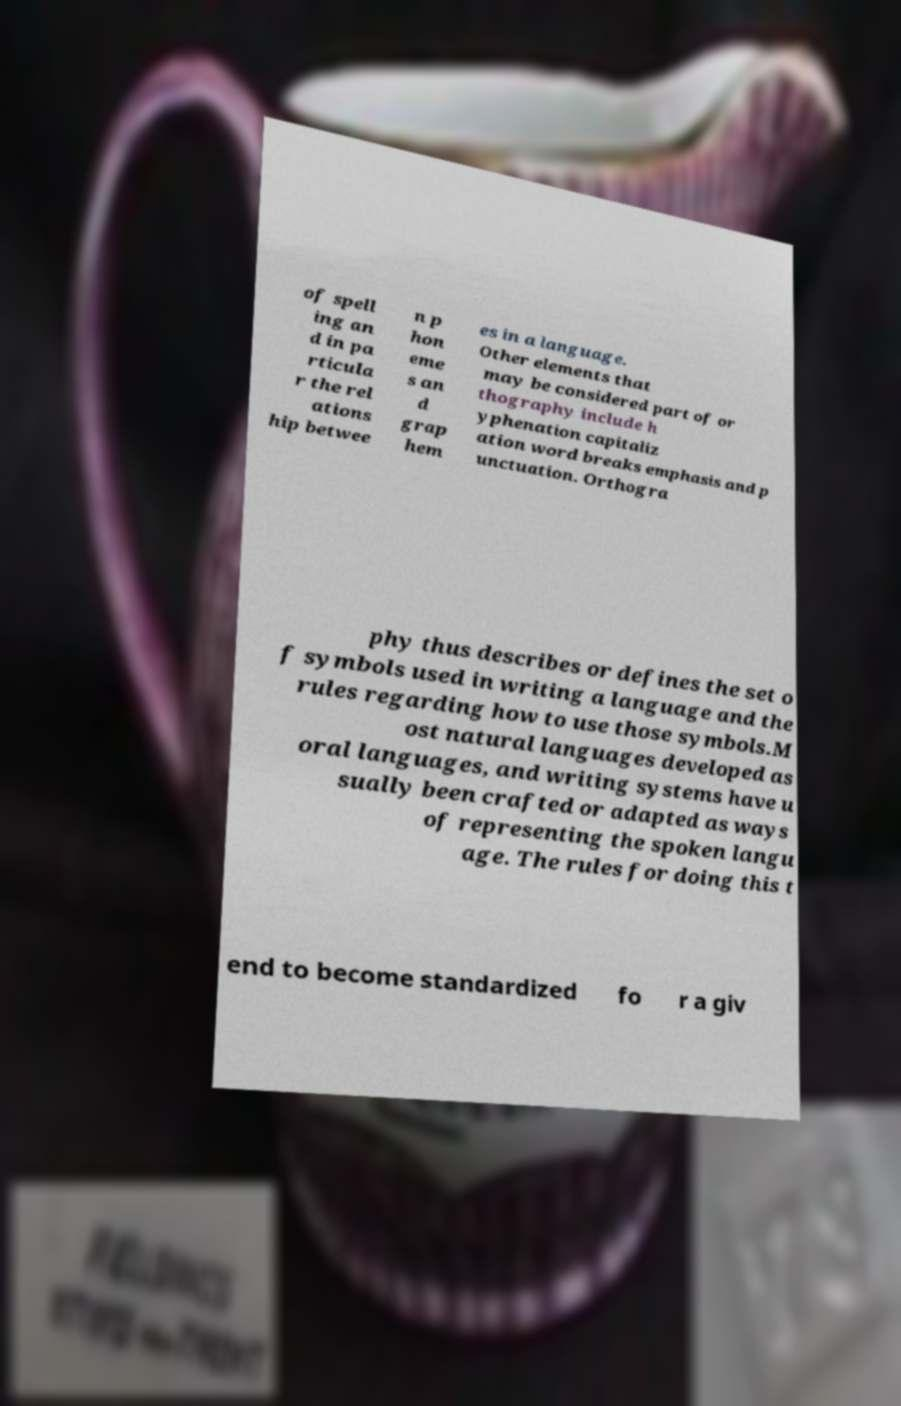What messages or text are displayed in this image? I need them in a readable, typed format. of spell ing an d in pa rticula r the rel ations hip betwee n p hon eme s an d grap hem es in a language. Other elements that may be considered part of or thography include h yphenation capitaliz ation word breaks emphasis and p unctuation. Orthogra phy thus describes or defines the set o f symbols used in writing a language and the rules regarding how to use those symbols.M ost natural languages developed as oral languages, and writing systems have u sually been crafted or adapted as ways of representing the spoken langu age. The rules for doing this t end to become standardized fo r a giv 